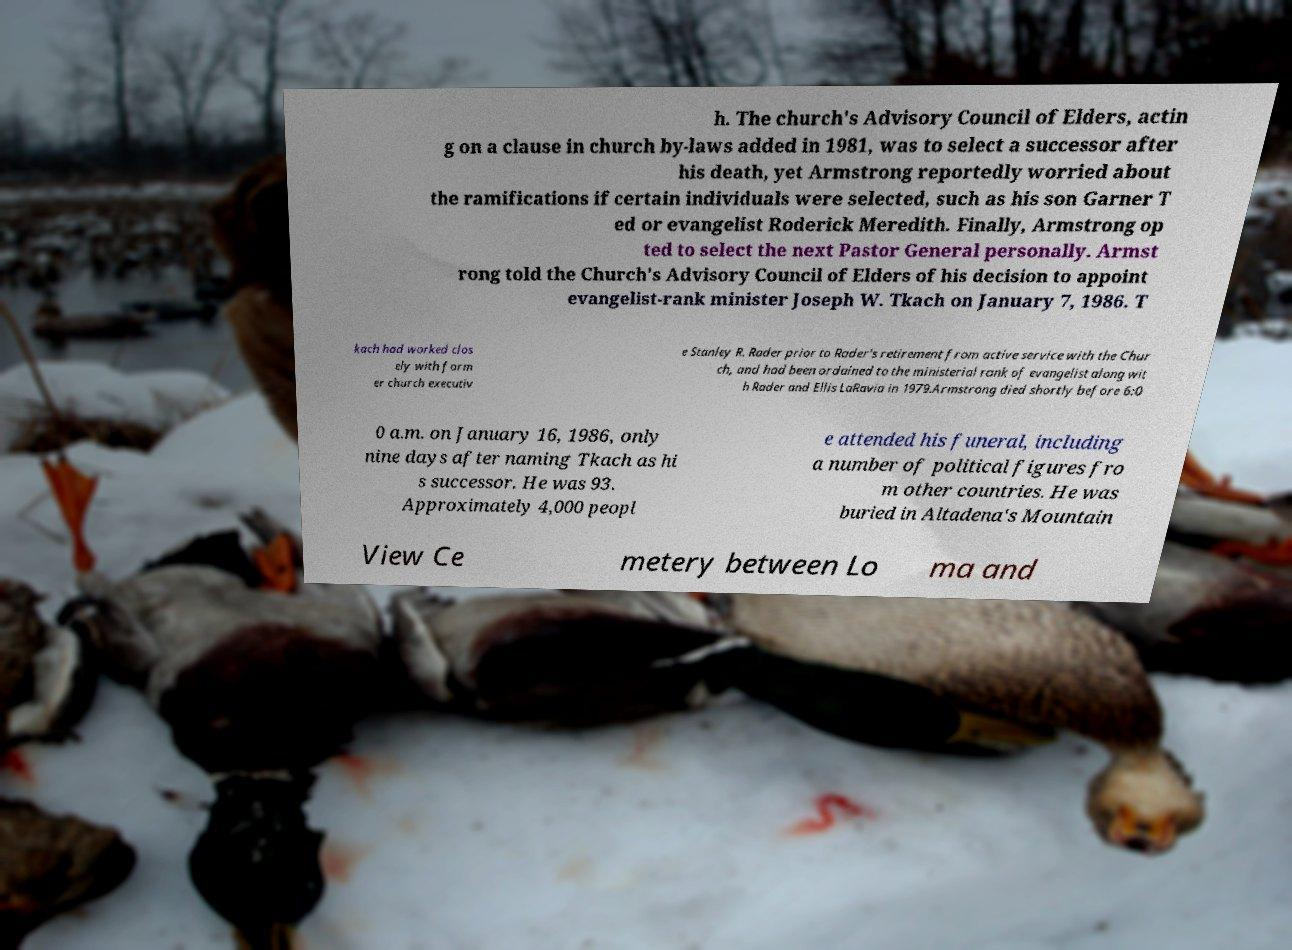What messages or text are displayed in this image? I need them in a readable, typed format. h. The church's Advisory Council of Elders, actin g on a clause in church by-laws added in 1981, was to select a successor after his death, yet Armstrong reportedly worried about the ramifications if certain individuals were selected, such as his son Garner T ed or evangelist Roderick Meredith. Finally, Armstrong op ted to select the next Pastor General personally. Armst rong told the Church's Advisory Council of Elders of his decision to appoint evangelist-rank minister Joseph W. Tkach on January 7, 1986. T kach had worked clos ely with form er church executiv e Stanley R. Rader prior to Rader's retirement from active service with the Chur ch, and had been ordained to the ministerial rank of evangelist along wit h Rader and Ellis LaRavia in 1979.Armstrong died shortly before 6:0 0 a.m. on January 16, 1986, only nine days after naming Tkach as hi s successor. He was 93. Approximately 4,000 peopl e attended his funeral, including a number of political figures fro m other countries. He was buried in Altadena's Mountain View Ce metery between Lo ma and 